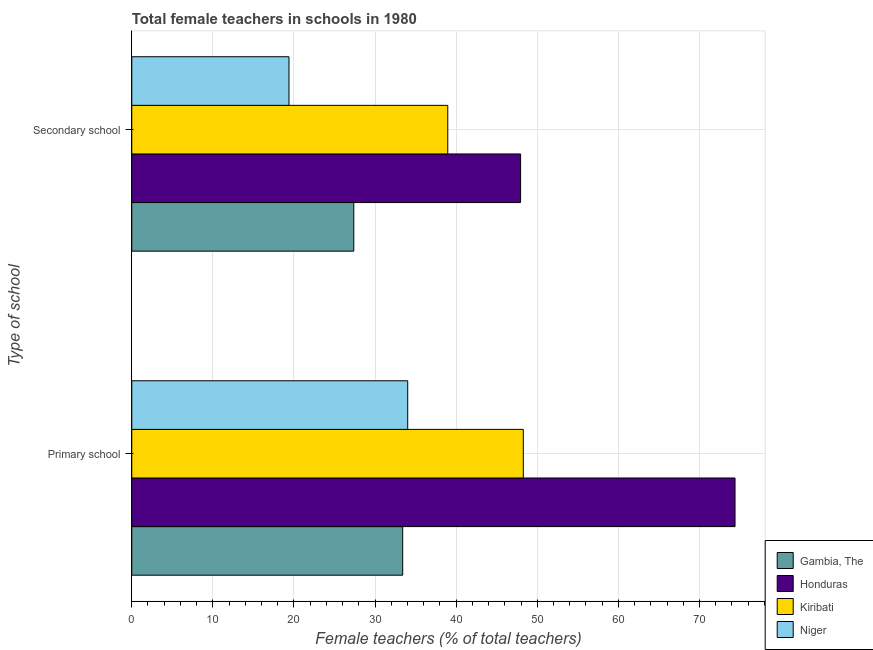Are the number of bars per tick equal to the number of legend labels?
Give a very brief answer. Yes. Are the number of bars on each tick of the Y-axis equal?
Make the answer very short. Yes. How many bars are there on the 1st tick from the bottom?
Offer a very short reply. 4. What is the label of the 2nd group of bars from the top?
Give a very brief answer. Primary school. What is the percentage of female teachers in secondary schools in Kiribati?
Your answer should be very brief. 38.96. Across all countries, what is the maximum percentage of female teachers in primary schools?
Provide a succinct answer. 74.38. Across all countries, what is the minimum percentage of female teachers in primary schools?
Your response must be concise. 33.41. In which country was the percentage of female teachers in primary schools maximum?
Provide a succinct answer. Honduras. In which country was the percentage of female teachers in primary schools minimum?
Ensure brevity in your answer.  Gambia, The. What is the total percentage of female teachers in secondary schools in the graph?
Your answer should be compact. 133.66. What is the difference between the percentage of female teachers in primary schools in Gambia, The and that in Kiribati?
Your response must be concise. -14.87. What is the difference between the percentage of female teachers in secondary schools in Honduras and the percentage of female teachers in primary schools in Gambia, The?
Your answer should be very brief. 14.53. What is the average percentage of female teachers in secondary schools per country?
Make the answer very short. 33.41. What is the difference between the percentage of female teachers in primary schools and percentage of female teachers in secondary schools in Gambia, The?
Your answer should be very brief. 6.03. What is the ratio of the percentage of female teachers in primary schools in Honduras to that in Niger?
Give a very brief answer. 2.19. Is the percentage of female teachers in primary schools in Niger less than that in Honduras?
Keep it short and to the point. Yes. In how many countries, is the percentage of female teachers in primary schools greater than the average percentage of female teachers in primary schools taken over all countries?
Offer a very short reply. 2. What does the 1st bar from the top in Primary school represents?
Your answer should be compact. Niger. What does the 3rd bar from the bottom in Primary school represents?
Your answer should be compact. Kiribati. How many bars are there?
Your answer should be compact. 8. Are all the bars in the graph horizontal?
Ensure brevity in your answer.  Yes. What is the difference between two consecutive major ticks on the X-axis?
Your answer should be very brief. 10. Are the values on the major ticks of X-axis written in scientific E-notation?
Give a very brief answer. No. Does the graph contain any zero values?
Ensure brevity in your answer.  No. Does the graph contain grids?
Provide a short and direct response. Yes. How are the legend labels stacked?
Ensure brevity in your answer.  Vertical. What is the title of the graph?
Make the answer very short. Total female teachers in schools in 1980. What is the label or title of the X-axis?
Your answer should be compact. Female teachers (% of total teachers). What is the label or title of the Y-axis?
Ensure brevity in your answer.  Type of school. What is the Female teachers (% of total teachers) in Gambia, The in Primary school?
Your answer should be compact. 33.41. What is the Female teachers (% of total teachers) in Honduras in Primary school?
Ensure brevity in your answer.  74.38. What is the Female teachers (% of total teachers) of Kiribati in Primary school?
Keep it short and to the point. 48.28. What is the Female teachers (% of total teachers) in Niger in Primary school?
Your answer should be compact. 34.02. What is the Female teachers (% of total teachers) of Gambia, The in Secondary school?
Your answer should be compact. 27.37. What is the Female teachers (% of total teachers) of Honduras in Secondary school?
Offer a terse response. 47.94. What is the Female teachers (% of total teachers) of Kiribati in Secondary school?
Ensure brevity in your answer.  38.96. What is the Female teachers (% of total teachers) of Niger in Secondary school?
Your answer should be compact. 19.38. Across all Type of school, what is the maximum Female teachers (% of total teachers) of Gambia, The?
Your answer should be compact. 33.41. Across all Type of school, what is the maximum Female teachers (% of total teachers) of Honduras?
Keep it short and to the point. 74.38. Across all Type of school, what is the maximum Female teachers (% of total teachers) of Kiribati?
Provide a short and direct response. 48.28. Across all Type of school, what is the maximum Female teachers (% of total teachers) of Niger?
Your response must be concise. 34.02. Across all Type of school, what is the minimum Female teachers (% of total teachers) in Gambia, The?
Provide a succinct answer. 27.37. Across all Type of school, what is the minimum Female teachers (% of total teachers) of Honduras?
Provide a short and direct response. 47.94. Across all Type of school, what is the minimum Female teachers (% of total teachers) of Kiribati?
Give a very brief answer. 38.96. Across all Type of school, what is the minimum Female teachers (% of total teachers) in Niger?
Ensure brevity in your answer.  19.38. What is the total Female teachers (% of total teachers) in Gambia, The in the graph?
Your answer should be compact. 60.78. What is the total Female teachers (% of total teachers) of Honduras in the graph?
Provide a short and direct response. 122.32. What is the total Female teachers (% of total teachers) in Kiribati in the graph?
Keep it short and to the point. 87.24. What is the total Female teachers (% of total teachers) in Niger in the graph?
Your response must be concise. 53.41. What is the difference between the Female teachers (% of total teachers) of Gambia, The in Primary school and that in Secondary school?
Ensure brevity in your answer.  6.03. What is the difference between the Female teachers (% of total teachers) of Honduras in Primary school and that in Secondary school?
Keep it short and to the point. 26.44. What is the difference between the Female teachers (% of total teachers) of Kiribati in Primary school and that in Secondary school?
Your response must be concise. 9.31. What is the difference between the Female teachers (% of total teachers) of Niger in Primary school and that in Secondary school?
Your response must be concise. 14.64. What is the difference between the Female teachers (% of total teachers) in Gambia, The in Primary school and the Female teachers (% of total teachers) in Honduras in Secondary school?
Provide a succinct answer. -14.53. What is the difference between the Female teachers (% of total teachers) of Gambia, The in Primary school and the Female teachers (% of total teachers) of Kiribati in Secondary school?
Make the answer very short. -5.56. What is the difference between the Female teachers (% of total teachers) of Gambia, The in Primary school and the Female teachers (% of total teachers) of Niger in Secondary school?
Ensure brevity in your answer.  14.02. What is the difference between the Female teachers (% of total teachers) of Honduras in Primary school and the Female teachers (% of total teachers) of Kiribati in Secondary school?
Offer a very short reply. 35.42. What is the difference between the Female teachers (% of total teachers) of Honduras in Primary school and the Female teachers (% of total teachers) of Niger in Secondary school?
Provide a short and direct response. 54.99. What is the difference between the Female teachers (% of total teachers) in Kiribati in Primary school and the Female teachers (% of total teachers) in Niger in Secondary school?
Your answer should be compact. 28.89. What is the average Female teachers (% of total teachers) of Gambia, The per Type of school?
Your answer should be compact. 30.39. What is the average Female teachers (% of total teachers) in Honduras per Type of school?
Offer a very short reply. 61.16. What is the average Female teachers (% of total teachers) in Kiribati per Type of school?
Your response must be concise. 43.62. What is the average Female teachers (% of total teachers) in Niger per Type of school?
Your answer should be very brief. 26.7. What is the difference between the Female teachers (% of total teachers) of Gambia, The and Female teachers (% of total teachers) of Honduras in Primary school?
Ensure brevity in your answer.  -40.97. What is the difference between the Female teachers (% of total teachers) of Gambia, The and Female teachers (% of total teachers) of Kiribati in Primary school?
Your answer should be very brief. -14.87. What is the difference between the Female teachers (% of total teachers) of Gambia, The and Female teachers (% of total teachers) of Niger in Primary school?
Ensure brevity in your answer.  -0.62. What is the difference between the Female teachers (% of total teachers) of Honduras and Female teachers (% of total teachers) of Kiribati in Primary school?
Your answer should be compact. 26.1. What is the difference between the Female teachers (% of total teachers) in Honduras and Female teachers (% of total teachers) in Niger in Primary school?
Make the answer very short. 40.36. What is the difference between the Female teachers (% of total teachers) of Kiribati and Female teachers (% of total teachers) of Niger in Primary school?
Provide a short and direct response. 14.25. What is the difference between the Female teachers (% of total teachers) of Gambia, The and Female teachers (% of total teachers) of Honduras in Secondary school?
Give a very brief answer. -20.57. What is the difference between the Female teachers (% of total teachers) of Gambia, The and Female teachers (% of total teachers) of Kiribati in Secondary school?
Keep it short and to the point. -11.59. What is the difference between the Female teachers (% of total teachers) in Gambia, The and Female teachers (% of total teachers) in Niger in Secondary school?
Keep it short and to the point. 7.99. What is the difference between the Female teachers (% of total teachers) of Honduras and Female teachers (% of total teachers) of Kiribati in Secondary school?
Your response must be concise. 8.98. What is the difference between the Female teachers (% of total teachers) in Honduras and Female teachers (% of total teachers) in Niger in Secondary school?
Give a very brief answer. 28.55. What is the difference between the Female teachers (% of total teachers) of Kiribati and Female teachers (% of total teachers) of Niger in Secondary school?
Keep it short and to the point. 19.58. What is the ratio of the Female teachers (% of total teachers) in Gambia, The in Primary school to that in Secondary school?
Keep it short and to the point. 1.22. What is the ratio of the Female teachers (% of total teachers) in Honduras in Primary school to that in Secondary school?
Offer a terse response. 1.55. What is the ratio of the Female teachers (% of total teachers) in Kiribati in Primary school to that in Secondary school?
Provide a succinct answer. 1.24. What is the ratio of the Female teachers (% of total teachers) in Niger in Primary school to that in Secondary school?
Offer a terse response. 1.76. What is the difference between the highest and the second highest Female teachers (% of total teachers) in Gambia, The?
Your response must be concise. 6.03. What is the difference between the highest and the second highest Female teachers (% of total teachers) in Honduras?
Make the answer very short. 26.44. What is the difference between the highest and the second highest Female teachers (% of total teachers) of Kiribati?
Offer a very short reply. 9.31. What is the difference between the highest and the second highest Female teachers (% of total teachers) of Niger?
Your answer should be very brief. 14.64. What is the difference between the highest and the lowest Female teachers (% of total teachers) of Gambia, The?
Offer a very short reply. 6.03. What is the difference between the highest and the lowest Female teachers (% of total teachers) of Honduras?
Make the answer very short. 26.44. What is the difference between the highest and the lowest Female teachers (% of total teachers) in Kiribati?
Your answer should be compact. 9.31. What is the difference between the highest and the lowest Female teachers (% of total teachers) in Niger?
Ensure brevity in your answer.  14.64. 